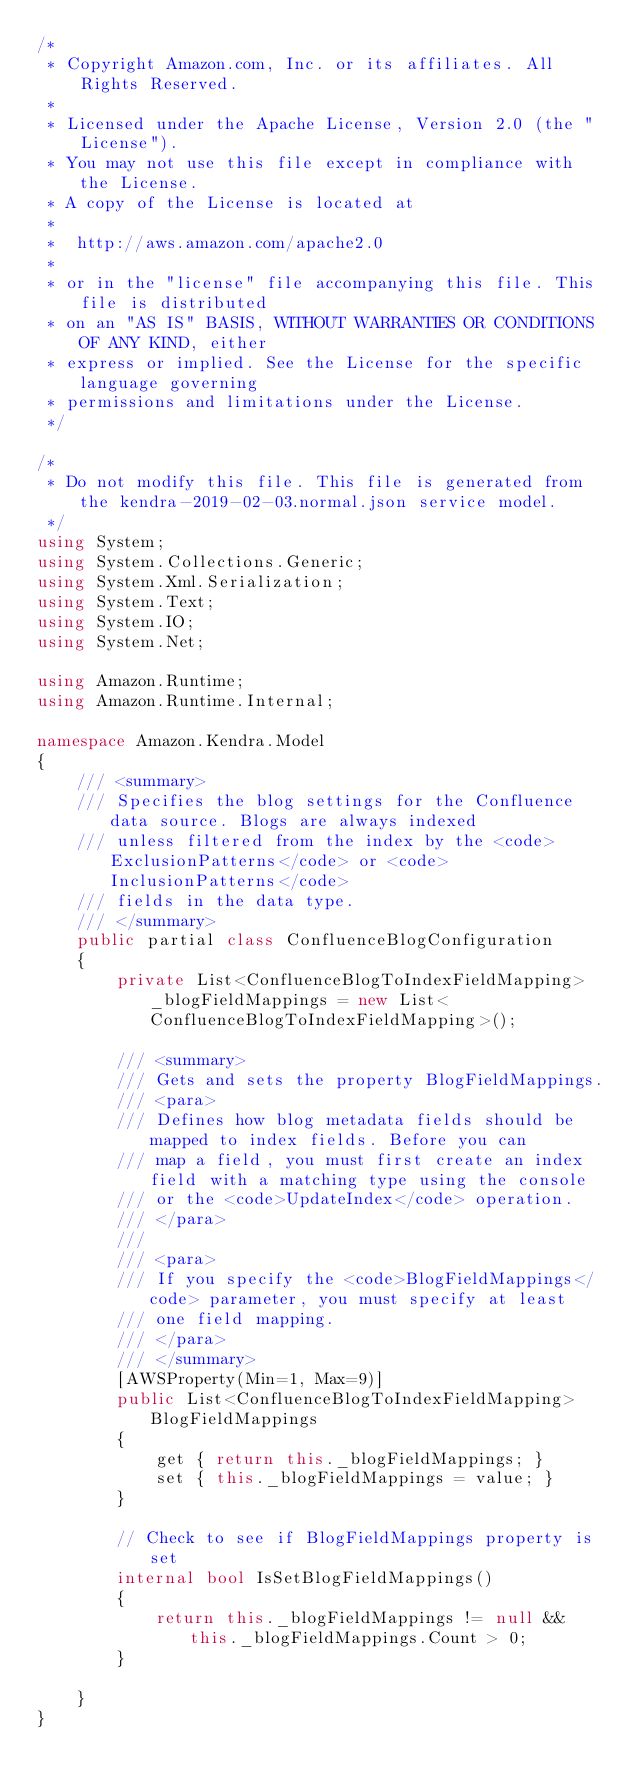Convert code to text. <code><loc_0><loc_0><loc_500><loc_500><_C#_>/*
 * Copyright Amazon.com, Inc. or its affiliates. All Rights Reserved.
 * 
 * Licensed under the Apache License, Version 2.0 (the "License").
 * You may not use this file except in compliance with the License.
 * A copy of the License is located at
 * 
 *  http://aws.amazon.com/apache2.0
 * 
 * or in the "license" file accompanying this file. This file is distributed
 * on an "AS IS" BASIS, WITHOUT WARRANTIES OR CONDITIONS OF ANY KIND, either
 * express or implied. See the License for the specific language governing
 * permissions and limitations under the License.
 */

/*
 * Do not modify this file. This file is generated from the kendra-2019-02-03.normal.json service model.
 */
using System;
using System.Collections.Generic;
using System.Xml.Serialization;
using System.Text;
using System.IO;
using System.Net;

using Amazon.Runtime;
using Amazon.Runtime.Internal;

namespace Amazon.Kendra.Model
{
    /// <summary>
    /// Specifies the blog settings for the Confluence data source. Blogs are always indexed
    /// unless filtered from the index by the <code>ExclusionPatterns</code> or <code>InclusionPatterns</code>
    /// fields in the data type.
    /// </summary>
    public partial class ConfluenceBlogConfiguration
    {
        private List<ConfluenceBlogToIndexFieldMapping> _blogFieldMappings = new List<ConfluenceBlogToIndexFieldMapping>();

        /// <summary>
        /// Gets and sets the property BlogFieldMappings. 
        /// <para>
        /// Defines how blog metadata fields should be mapped to index fields. Before you can
        /// map a field, you must first create an index field with a matching type using the console
        /// or the <code>UpdateIndex</code> operation.
        /// </para>
        ///  
        /// <para>
        /// If you specify the <code>BlogFieldMappings</code> parameter, you must specify at least
        /// one field mapping.
        /// </para>
        /// </summary>
        [AWSProperty(Min=1, Max=9)]
        public List<ConfluenceBlogToIndexFieldMapping> BlogFieldMappings
        {
            get { return this._blogFieldMappings; }
            set { this._blogFieldMappings = value; }
        }

        // Check to see if BlogFieldMappings property is set
        internal bool IsSetBlogFieldMappings()
        {
            return this._blogFieldMappings != null && this._blogFieldMappings.Count > 0; 
        }

    }
}</code> 